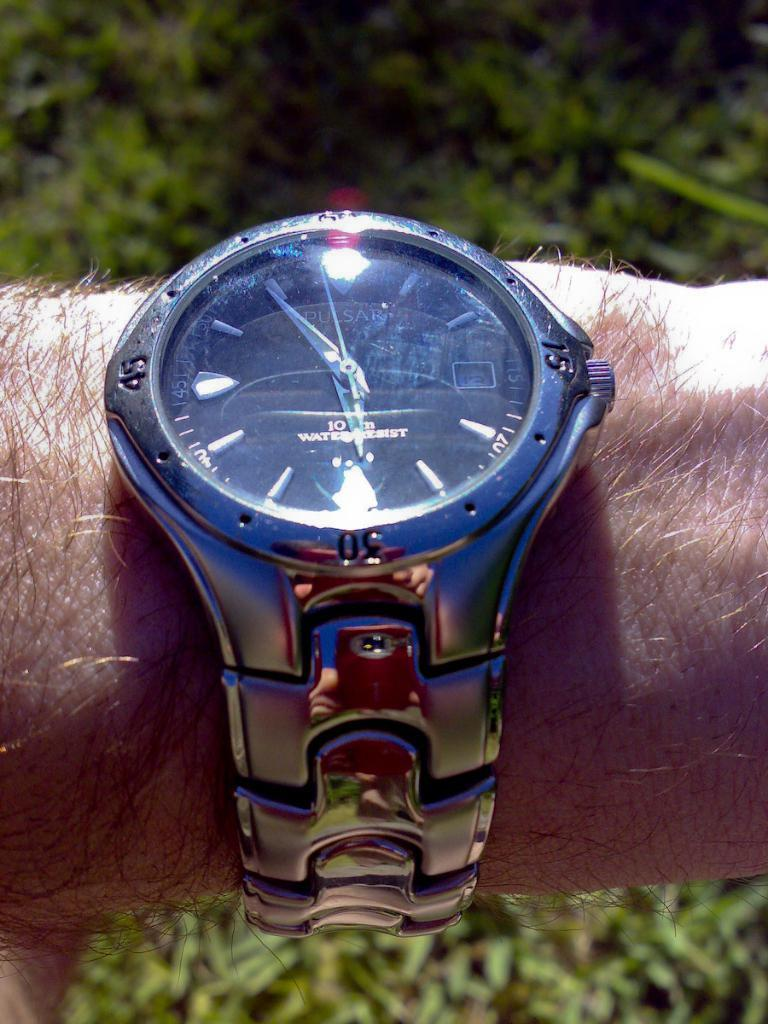<image>
Describe the image concisely. A Pulsar wristwatch is touted as being water resistant. 